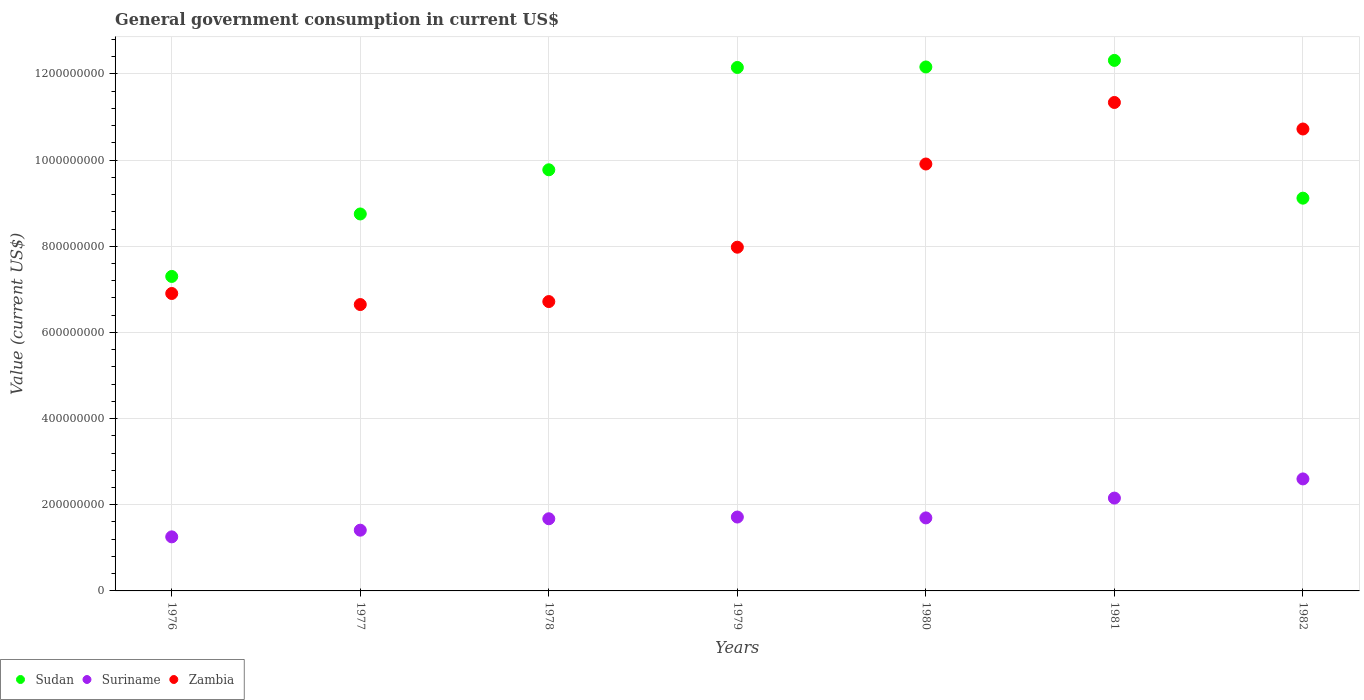Is the number of dotlines equal to the number of legend labels?
Provide a succinct answer. Yes. What is the government conusmption in Suriname in 1979?
Provide a succinct answer. 1.72e+08. Across all years, what is the maximum government conusmption in Zambia?
Your answer should be very brief. 1.13e+09. Across all years, what is the minimum government conusmption in Suriname?
Provide a short and direct response. 1.26e+08. In which year was the government conusmption in Suriname minimum?
Provide a short and direct response. 1976. What is the total government conusmption in Suriname in the graph?
Keep it short and to the point. 1.25e+09. What is the difference between the government conusmption in Sudan in 1976 and that in 1977?
Ensure brevity in your answer.  -1.45e+08. What is the difference between the government conusmption in Zambia in 1978 and the government conusmption in Suriname in 1982?
Your answer should be compact. 4.12e+08. What is the average government conusmption in Zambia per year?
Provide a succinct answer. 8.60e+08. In the year 1980, what is the difference between the government conusmption in Zambia and government conusmption in Suriname?
Your response must be concise. 8.22e+08. What is the ratio of the government conusmption in Sudan in 1976 to that in 1979?
Your response must be concise. 0.6. What is the difference between the highest and the second highest government conusmption in Zambia?
Your answer should be very brief. 6.16e+07. What is the difference between the highest and the lowest government conusmption in Zambia?
Keep it short and to the point. 4.69e+08. Is it the case that in every year, the sum of the government conusmption in Sudan and government conusmption in Suriname  is greater than the government conusmption in Zambia?
Make the answer very short. Yes. Is the government conusmption in Suriname strictly greater than the government conusmption in Sudan over the years?
Your answer should be compact. No. Is the government conusmption in Zambia strictly less than the government conusmption in Sudan over the years?
Make the answer very short. No. How many dotlines are there?
Your answer should be compact. 3. What is the difference between two consecutive major ticks on the Y-axis?
Ensure brevity in your answer.  2.00e+08. Does the graph contain grids?
Ensure brevity in your answer.  Yes. What is the title of the graph?
Your response must be concise. General government consumption in current US$. What is the label or title of the X-axis?
Your answer should be compact. Years. What is the label or title of the Y-axis?
Ensure brevity in your answer.  Value (current US$). What is the Value (current US$) of Sudan in 1976?
Give a very brief answer. 7.30e+08. What is the Value (current US$) in Suriname in 1976?
Provide a succinct answer. 1.26e+08. What is the Value (current US$) of Zambia in 1976?
Offer a very short reply. 6.90e+08. What is the Value (current US$) in Sudan in 1977?
Make the answer very short. 8.75e+08. What is the Value (current US$) of Suriname in 1977?
Keep it short and to the point. 1.41e+08. What is the Value (current US$) in Zambia in 1977?
Offer a very short reply. 6.65e+08. What is the Value (current US$) of Sudan in 1978?
Give a very brief answer. 9.78e+08. What is the Value (current US$) of Suriname in 1978?
Make the answer very short. 1.68e+08. What is the Value (current US$) in Zambia in 1978?
Offer a very short reply. 6.72e+08. What is the Value (current US$) of Sudan in 1979?
Make the answer very short. 1.22e+09. What is the Value (current US$) of Suriname in 1979?
Your response must be concise. 1.72e+08. What is the Value (current US$) in Zambia in 1979?
Provide a succinct answer. 7.98e+08. What is the Value (current US$) in Sudan in 1980?
Provide a short and direct response. 1.22e+09. What is the Value (current US$) in Suriname in 1980?
Make the answer very short. 1.70e+08. What is the Value (current US$) in Zambia in 1980?
Your response must be concise. 9.91e+08. What is the Value (current US$) in Sudan in 1981?
Keep it short and to the point. 1.23e+09. What is the Value (current US$) of Suriname in 1981?
Your response must be concise. 2.16e+08. What is the Value (current US$) in Zambia in 1981?
Offer a very short reply. 1.13e+09. What is the Value (current US$) in Sudan in 1982?
Your answer should be very brief. 9.12e+08. What is the Value (current US$) of Suriname in 1982?
Make the answer very short. 2.60e+08. What is the Value (current US$) in Zambia in 1982?
Your response must be concise. 1.07e+09. Across all years, what is the maximum Value (current US$) in Sudan?
Your response must be concise. 1.23e+09. Across all years, what is the maximum Value (current US$) of Suriname?
Keep it short and to the point. 2.60e+08. Across all years, what is the maximum Value (current US$) of Zambia?
Make the answer very short. 1.13e+09. Across all years, what is the minimum Value (current US$) of Sudan?
Offer a very short reply. 7.30e+08. Across all years, what is the minimum Value (current US$) of Suriname?
Provide a succinct answer. 1.26e+08. Across all years, what is the minimum Value (current US$) of Zambia?
Provide a short and direct response. 6.65e+08. What is the total Value (current US$) in Sudan in the graph?
Provide a succinct answer. 7.16e+09. What is the total Value (current US$) in Suriname in the graph?
Give a very brief answer. 1.25e+09. What is the total Value (current US$) of Zambia in the graph?
Provide a short and direct response. 6.02e+09. What is the difference between the Value (current US$) in Sudan in 1976 and that in 1977?
Your answer should be very brief. -1.45e+08. What is the difference between the Value (current US$) of Suriname in 1976 and that in 1977?
Offer a very short reply. -1.55e+07. What is the difference between the Value (current US$) in Zambia in 1976 and that in 1977?
Your answer should be very brief. 2.57e+07. What is the difference between the Value (current US$) in Sudan in 1976 and that in 1978?
Your answer should be very brief. -2.48e+08. What is the difference between the Value (current US$) in Suriname in 1976 and that in 1978?
Ensure brevity in your answer.  -4.20e+07. What is the difference between the Value (current US$) of Zambia in 1976 and that in 1978?
Your answer should be very brief. 1.88e+07. What is the difference between the Value (current US$) of Sudan in 1976 and that in 1979?
Your answer should be very brief. -4.85e+08. What is the difference between the Value (current US$) in Suriname in 1976 and that in 1979?
Your answer should be very brief. -4.60e+07. What is the difference between the Value (current US$) of Zambia in 1976 and that in 1979?
Provide a succinct answer. -1.07e+08. What is the difference between the Value (current US$) in Sudan in 1976 and that in 1980?
Offer a terse response. -4.86e+08. What is the difference between the Value (current US$) of Suriname in 1976 and that in 1980?
Keep it short and to the point. -4.40e+07. What is the difference between the Value (current US$) in Zambia in 1976 and that in 1980?
Your answer should be compact. -3.01e+08. What is the difference between the Value (current US$) in Sudan in 1976 and that in 1981?
Offer a terse response. -5.02e+08. What is the difference between the Value (current US$) of Suriname in 1976 and that in 1981?
Ensure brevity in your answer.  -9.00e+07. What is the difference between the Value (current US$) in Zambia in 1976 and that in 1981?
Keep it short and to the point. -4.43e+08. What is the difference between the Value (current US$) in Sudan in 1976 and that in 1982?
Ensure brevity in your answer.  -1.82e+08. What is the difference between the Value (current US$) of Suriname in 1976 and that in 1982?
Keep it short and to the point. -1.34e+08. What is the difference between the Value (current US$) in Zambia in 1976 and that in 1982?
Offer a very short reply. -3.82e+08. What is the difference between the Value (current US$) in Sudan in 1977 and that in 1978?
Ensure brevity in your answer.  -1.03e+08. What is the difference between the Value (current US$) of Suriname in 1977 and that in 1978?
Make the answer very short. -2.65e+07. What is the difference between the Value (current US$) in Zambia in 1977 and that in 1978?
Ensure brevity in your answer.  -6.90e+06. What is the difference between the Value (current US$) of Sudan in 1977 and that in 1979?
Ensure brevity in your answer.  -3.40e+08. What is the difference between the Value (current US$) in Suriname in 1977 and that in 1979?
Offer a terse response. -3.05e+07. What is the difference between the Value (current US$) of Zambia in 1977 and that in 1979?
Your answer should be compact. -1.33e+08. What is the difference between the Value (current US$) of Sudan in 1977 and that in 1980?
Provide a short and direct response. -3.41e+08. What is the difference between the Value (current US$) of Suriname in 1977 and that in 1980?
Your answer should be compact. -2.85e+07. What is the difference between the Value (current US$) in Zambia in 1977 and that in 1980?
Keep it short and to the point. -3.26e+08. What is the difference between the Value (current US$) of Sudan in 1977 and that in 1981?
Ensure brevity in your answer.  -3.56e+08. What is the difference between the Value (current US$) in Suriname in 1977 and that in 1981?
Your response must be concise. -7.45e+07. What is the difference between the Value (current US$) of Zambia in 1977 and that in 1981?
Ensure brevity in your answer.  -4.69e+08. What is the difference between the Value (current US$) of Sudan in 1977 and that in 1982?
Keep it short and to the point. -3.67e+07. What is the difference between the Value (current US$) of Suriname in 1977 and that in 1982?
Provide a short and direct response. -1.19e+08. What is the difference between the Value (current US$) of Zambia in 1977 and that in 1982?
Provide a succinct answer. -4.08e+08. What is the difference between the Value (current US$) in Sudan in 1978 and that in 1979?
Ensure brevity in your answer.  -2.38e+08. What is the difference between the Value (current US$) in Zambia in 1978 and that in 1979?
Offer a terse response. -1.26e+08. What is the difference between the Value (current US$) in Sudan in 1978 and that in 1980?
Offer a terse response. -2.39e+08. What is the difference between the Value (current US$) in Zambia in 1978 and that in 1980?
Ensure brevity in your answer.  -3.19e+08. What is the difference between the Value (current US$) of Sudan in 1978 and that in 1981?
Offer a very short reply. -2.54e+08. What is the difference between the Value (current US$) of Suriname in 1978 and that in 1981?
Offer a terse response. -4.80e+07. What is the difference between the Value (current US$) in Zambia in 1978 and that in 1981?
Provide a short and direct response. -4.62e+08. What is the difference between the Value (current US$) in Sudan in 1978 and that in 1982?
Offer a terse response. 6.59e+07. What is the difference between the Value (current US$) in Suriname in 1978 and that in 1982?
Give a very brief answer. -9.25e+07. What is the difference between the Value (current US$) in Zambia in 1978 and that in 1982?
Offer a terse response. -4.01e+08. What is the difference between the Value (current US$) of Sudan in 1979 and that in 1980?
Your answer should be very brief. -1.16e+06. What is the difference between the Value (current US$) in Suriname in 1979 and that in 1980?
Your answer should be compact. 2.00e+06. What is the difference between the Value (current US$) of Zambia in 1979 and that in 1980?
Provide a succinct answer. -1.93e+08. What is the difference between the Value (current US$) of Sudan in 1979 and that in 1981?
Your response must be concise. -1.64e+07. What is the difference between the Value (current US$) in Suriname in 1979 and that in 1981?
Keep it short and to the point. -4.40e+07. What is the difference between the Value (current US$) in Zambia in 1979 and that in 1981?
Provide a succinct answer. -3.36e+08. What is the difference between the Value (current US$) in Sudan in 1979 and that in 1982?
Provide a short and direct response. 3.03e+08. What is the difference between the Value (current US$) of Suriname in 1979 and that in 1982?
Ensure brevity in your answer.  -8.85e+07. What is the difference between the Value (current US$) in Zambia in 1979 and that in 1982?
Your answer should be compact. -2.74e+08. What is the difference between the Value (current US$) of Sudan in 1980 and that in 1981?
Ensure brevity in your answer.  -1.52e+07. What is the difference between the Value (current US$) of Suriname in 1980 and that in 1981?
Your answer should be very brief. -4.60e+07. What is the difference between the Value (current US$) in Zambia in 1980 and that in 1981?
Give a very brief answer. -1.43e+08. What is the difference between the Value (current US$) in Sudan in 1980 and that in 1982?
Provide a succinct answer. 3.05e+08. What is the difference between the Value (current US$) in Suriname in 1980 and that in 1982?
Give a very brief answer. -9.05e+07. What is the difference between the Value (current US$) of Zambia in 1980 and that in 1982?
Your response must be concise. -8.13e+07. What is the difference between the Value (current US$) of Sudan in 1981 and that in 1982?
Your answer should be compact. 3.20e+08. What is the difference between the Value (current US$) of Suriname in 1981 and that in 1982?
Provide a succinct answer. -4.45e+07. What is the difference between the Value (current US$) of Zambia in 1981 and that in 1982?
Provide a succinct answer. 6.16e+07. What is the difference between the Value (current US$) of Sudan in 1976 and the Value (current US$) of Suriname in 1977?
Provide a short and direct response. 5.89e+08. What is the difference between the Value (current US$) in Sudan in 1976 and the Value (current US$) in Zambia in 1977?
Your answer should be very brief. 6.53e+07. What is the difference between the Value (current US$) of Suriname in 1976 and the Value (current US$) of Zambia in 1977?
Your response must be concise. -5.39e+08. What is the difference between the Value (current US$) of Sudan in 1976 and the Value (current US$) of Suriname in 1978?
Make the answer very short. 5.63e+08. What is the difference between the Value (current US$) of Sudan in 1976 and the Value (current US$) of Zambia in 1978?
Make the answer very short. 5.83e+07. What is the difference between the Value (current US$) in Suriname in 1976 and the Value (current US$) in Zambia in 1978?
Give a very brief answer. -5.46e+08. What is the difference between the Value (current US$) in Sudan in 1976 and the Value (current US$) in Suriname in 1979?
Provide a succinct answer. 5.59e+08. What is the difference between the Value (current US$) in Sudan in 1976 and the Value (current US$) in Zambia in 1979?
Offer a very short reply. -6.79e+07. What is the difference between the Value (current US$) of Suriname in 1976 and the Value (current US$) of Zambia in 1979?
Ensure brevity in your answer.  -6.72e+08. What is the difference between the Value (current US$) of Sudan in 1976 and the Value (current US$) of Suriname in 1980?
Your answer should be very brief. 5.61e+08. What is the difference between the Value (current US$) in Sudan in 1976 and the Value (current US$) in Zambia in 1980?
Offer a terse response. -2.61e+08. What is the difference between the Value (current US$) in Suriname in 1976 and the Value (current US$) in Zambia in 1980?
Offer a terse response. -8.66e+08. What is the difference between the Value (current US$) in Sudan in 1976 and the Value (current US$) in Suriname in 1981?
Provide a short and direct response. 5.15e+08. What is the difference between the Value (current US$) in Sudan in 1976 and the Value (current US$) in Zambia in 1981?
Ensure brevity in your answer.  -4.04e+08. What is the difference between the Value (current US$) in Suriname in 1976 and the Value (current US$) in Zambia in 1981?
Offer a terse response. -1.01e+09. What is the difference between the Value (current US$) in Sudan in 1976 and the Value (current US$) in Suriname in 1982?
Keep it short and to the point. 4.70e+08. What is the difference between the Value (current US$) in Sudan in 1976 and the Value (current US$) in Zambia in 1982?
Provide a succinct answer. -3.42e+08. What is the difference between the Value (current US$) in Suriname in 1976 and the Value (current US$) in Zambia in 1982?
Make the answer very short. -9.47e+08. What is the difference between the Value (current US$) in Sudan in 1977 and the Value (current US$) in Suriname in 1978?
Keep it short and to the point. 7.08e+08. What is the difference between the Value (current US$) of Sudan in 1977 and the Value (current US$) of Zambia in 1978?
Provide a succinct answer. 2.03e+08. What is the difference between the Value (current US$) of Suriname in 1977 and the Value (current US$) of Zambia in 1978?
Give a very brief answer. -5.31e+08. What is the difference between the Value (current US$) of Sudan in 1977 and the Value (current US$) of Suriname in 1979?
Make the answer very short. 7.04e+08. What is the difference between the Value (current US$) of Sudan in 1977 and the Value (current US$) of Zambia in 1979?
Keep it short and to the point. 7.72e+07. What is the difference between the Value (current US$) of Suriname in 1977 and the Value (current US$) of Zambia in 1979?
Your answer should be very brief. -6.57e+08. What is the difference between the Value (current US$) of Sudan in 1977 and the Value (current US$) of Suriname in 1980?
Offer a very short reply. 7.06e+08. What is the difference between the Value (current US$) in Sudan in 1977 and the Value (current US$) in Zambia in 1980?
Offer a terse response. -1.16e+08. What is the difference between the Value (current US$) of Suriname in 1977 and the Value (current US$) of Zambia in 1980?
Ensure brevity in your answer.  -8.50e+08. What is the difference between the Value (current US$) of Sudan in 1977 and the Value (current US$) of Suriname in 1981?
Offer a very short reply. 6.60e+08. What is the difference between the Value (current US$) of Sudan in 1977 and the Value (current US$) of Zambia in 1981?
Provide a short and direct response. -2.59e+08. What is the difference between the Value (current US$) in Suriname in 1977 and the Value (current US$) in Zambia in 1981?
Your answer should be very brief. -9.93e+08. What is the difference between the Value (current US$) in Sudan in 1977 and the Value (current US$) in Suriname in 1982?
Make the answer very short. 6.15e+08. What is the difference between the Value (current US$) in Sudan in 1977 and the Value (current US$) in Zambia in 1982?
Keep it short and to the point. -1.97e+08. What is the difference between the Value (current US$) of Suriname in 1977 and the Value (current US$) of Zambia in 1982?
Your answer should be compact. -9.31e+08. What is the difference between the Value (current US$) in Sudan in 1978 and the Value (current US$) in Suriname in 1979?
Offer a very short reply. 8.06e+08. What is the difference between the Value (current US$) in Sudan in 1978 and the Value (current US$) in Zambia in 1979?
Provide a succinct answer. 1.80e+08. What is the difference between the Value (current US$) of Suriname in 1978 and the Value (current US$) of Zambia in 1979?
Offer a terse response. -6.30e+08. What is the difference between the Value (current US$) of Sudan in 1978 and the Value (current US$) of Suriname in 1980?
Give a very brief answer. 8.08e+08. What is the difference between the Value (current US$) in Sudan in 1978 and the Value (current US$) in Zambia in 1980?
Offer a very short reply. -1.34e+07. What is the difference between the Value (current US$) of Suriname in 1978 and the Value (current US$) of Zambia in 1980?
Offer a very short reply. -8.24e+08. What is the difference between the Value (current US$) of Sudan in 1978 and the Value (current US$) of Suriname in 1981?
Provide a short and direct response. 7.62e+08. What is the difference between the Value (current US$) in Sudan in 1978 and the Value (current US$) in Zambia in 1981?
Offer a terse response. -1.56e+08. What is the difference between the Value (current US$) in Suriname in 1978 and the Value (current US$) in Zambia in 1981?
Your answer should be very brief. -9.66e+08. What is the difference between the Value (current US$) in Sudan in 1978 and the Value (current US$) in Suriname in 1982?
Your answer should be very brief. 7.18e+08. What is the difference between the Value (current US$) in Sudan in 1978 and the Value (current US$) in Zambia in 1982?
Keep it short and to the point. -9.47e+07. What is the difference between the Value (current US$) of Suriname in 1978 and the Value (current US$) of Zambia in 1982?
Your answer should be very brief. -9.05e+08. What is the difference between the Value (current US$) of Sudan in 1979 and the Value (current US$) of Suriname in 1980?
Provide a succinct answer. 1.05e+09. What is the difference between the Value (current US$) of Sudan in 1979 and the Value (current US$) of Zambia in 1980?
Provide a succinct answer. 2.24e+08. What is the difference between the Value (current US$) of Suriname in 1979 and the Value (current US$) of Zambia in 1980?
Provide a short and direct response. -8.20e+08. What is the difference between the Value (current US$) in Sudan in 1979 and the Value (current US$) in Suriname in 1981?
Your answer should be very brief. 1.00e+09. What is the difference between the Value (current US$) of Sudan in 1979 and the Value (current US$) of Zambia in 1981?
Your response must be concise. 8.13e+07. What is the difference between the Value (current US$) of Suriname in 1979 and the Value (current US$) of Zambia in 1981?
Your answer should be compact. -9.62e+08. What is the difference between the Value (current US$) in Sudan in 1979 and the Value (current US$) in Suriname in 1982?
Provide a succinct answer. 9.55e+08. What is the difference between the Value (current US$) of Sudan in 1979 and the Value (current US$) of Zambia in 1982?
Your answer should be very brief. 1.43e+08. What is the difference between the Value (current US$) in Suriname in 1979 and the Value (current US$) in Zambia in 1982?
Make the answer very short. -9.01e+08. What is the difference between the Value (current US$) of Sudan in 1980 and the Value (current US$) of Suriname in 1981?
Provide a short and direct response. 1.00e+09. What is the difference between the Value (current US$) of Sudan in 1980 and the Value (current US$) of Zambia in 1981?
Provide a short and direct response. 8.24e+07. What is the difference between the Value (current US$) of Suriname in 1980 and the Value (current US$) of Zambia in 1981?
Give a very brief answer. -9.64e+08. What is the difference between the Value (current US$) in Sudan in 1980 and the Value (current US$) in Suriname in 1982?
Your response must be concise. 9.56e+08. What is the difference between the Value (current US$) of Sudan in 1980 and the Value (current US$) of Zambia in 1982?
Your answer should be very brief. 1.44e+08. What is the difference between the Value (current US$) of Suriname in 1980 and the Value (current US$) of Zambia in 1982?
Offer a terse response. -9.03e+08. What is the difference between the Value (current US$) in Sudan in 1981 and the Value (current US$) in Suriname in 1982?
Ensure brevity in your answer.  9.72e+08. What is the difference between the Value (current US$) in Sudan in 1981 and the Value (current US$) in Zambia in 1982?
Provide a short and direct response. 1.59e+08. What is the difference between the Value (current US$) in Suriname in 1981 and the Value (current US$) in Zambia in 1982?
Offer a terse response. -8.57e+08. What is the average Value (current US$) of Sudan per year?
Your answer should be compact. 1.02e+09. What is the average Value (current US$) in Suriname per year?
Offer a terse response. 1.79e+08. What is the average Value (current US$) in Zambia per year?
Provide a succinct answer. 8.60e+08. In the year 1976, what is the difference between the Value (current US$) of Sudan and Value (current US$) of Suriname?
Offer a terse response. 6.05e+08. In the year 1976, what is the difference between the Value (current US$) of Sudan and Value (current US$) of Zambia?
Make the answer very short. 3.96e+07. In the year 1976, what is the difference between the Value (current US$) of Suriname and Value (current US$) of Zambia?
Your answer should be compact. -5.65e+08. In the year 1977, what is the difference between the Value (current US$) in Sudan and Value (current US$) in Suriname?
Your answer should be very brief. 7.34e+08. In the year 1977, what is the difference between the Value (current US$) in Sudan and Value (current US$) in Zambia?
Your response must be concise. 2.10e+08. In the year 1977, what is the difference between the Value (current US$) of Suriname and Value (current US$) of Zambia?
Offer a terse response. -5.24e+08. In the year 1978, what is the difference between the Value (current US$) in Sudan and Value (current US$) in Suriname?
Your answer should be very brief. 8.10e+08. In the year 1978, what is the difference between the Value (current US$) of Sudan and Value (current US$) of Zambia?
Offer a terse response. 3.06e+08. In the year 1978, what is the difference between the Value (current US$) in Suriname and Value (current US$) in Zambia?
Give a very brief answer. -5.04e+08. In the year 1979, what is the difference between the Value (current US$) in Sudan and Value (current US$) in Suriname?
Keep it short and to the point. 1.04e+09. In the year 1979, what is the difference between the Value (current US$) of Sudan and Value (current US$) of Zambia?
Keep it short and to the point. 4.17e+08. In the year 1979, what is the difference between the Value (current US$) in Suriname and Value (current US$) in Zambia?
Provide a short and direct response. -6.26e+08. In the year 1980, what is the difference between the Value (current US$) of Sudan and Value (current US$) of Suriname?
Keep it short and to the point. 1.05e+09. In the year 1980, what is the difference between the Value (current US$) of Sudan and Value (current US$) of Zambia?
Your answer should be compact. 2.25e+08. In the year 1980, what is the difference between the Value (current US$) in Suriname and Value (current US$) in Zambia?
Make the answer very short. -8.22e+08. In the year 1981, what is the difference between the Value (current US$) of Sudan and Value (current US$) of Suriname?
Your response must be concise. 1.02e+09. In the year 1981, what is the difference between the Value (current US$) of Sudan and Value (current US$) of Zambia?
Provide a short and direct response. 9.77e+07. In the year 1981, what is the difference between the Value (current US$) in Suriname and Value (current US$) in Zambia?
Your response must be concise. -9.18e+08. In the year 1982, what is the difference between the Value (current US$) of Sudan and Value (current US$) of Suriname?
Offer a very short reply. 6.52e+08. In the year 1982, what is the difference between the Value (current US$) of Sudan and Value (current US$) of Zambia?
Provide a short and direct response. -1.61e+08. In the year 1982, what is the difference between the Value (current US$) of Suriname and Value (current US$) of Zambia?
Provide a short and direct response. -8.12e+08. What is the ratio of the Value (current US$) in Sudan in 1976 to that in 1977?
Keep it short and to the point. 0.83. What is the ratio of the Value (current US$) of Suriname in 1976 to that in 1977?
Give a very brief answer. 0.89. What is the ratio of the Value (current US$) in Zambia in 1976 to that in 1977?
Give a very brief answer. 1.04. What is the ratio of the Value (current US$) in Sudan in 1976 to that in 1978?
Ensure brevity in your answer.  0.75. What is the ratio of the Value (current US$) in Suriname in 1976 to that in 1978?
Ensure brevity in your answer.  0.75. What is the ratio of the Value (current US$) in Zambia in 1976 to that in 1978?
Your answer should be compact. 1.03. What is the ratio of the Value (current US$) in Sudan in 1976 to that in 1979?
Offer a terse response. 0.6. What is the ratio of the Value (current US$) in Suriname in 1976 to that in 1979?
Ensure brevity in your answer.  0.73. What is the ratio of the Value (current US$) in Zambia in 1976 to that in 1979?
Ensure brevity in your answer.  0.87. What is the ratio of the Value (current US$) in Sudan in 1976 to that in 1980?
Provide a succinct answer. 0.6. What is the ratio of the Value (current US$) of Suriname in 1976 to that in 1980?
Your answer should be compact. 0.74. What is the ratio of the Value (current US$) in Zambia in 1976 to that in 1980?
Ensure brevity in your answer.  0.7. What is the ratio of the Value (current US$) of Sudan in 1976 to that in 1981?
Provide a succinct answer. 0.59. What is the ratio of the Value (current US$) of Suriname in 1976 to that in 1981?
Ensure brevity in your answer.  0.58. What is the ratio of the Value (current US$) of Zambia in 1976 to that in 1981?
Make the answer very short. 0.61. What is the ratio of the Value (current US$) of Sudan in 1976 to that in 1982?
Make the answer very short. 0.8. What is the ratio of the Value (current US$) of Suriname in 1976 to that in 1982?
Your answer should be compact. 0.48. What is the ratio of the Value (current US$) of Zambia in 1976 to that in 1982?
Offer a very short reply. 0.64. What is the ratio of the Value (current US$) of Sudan in 1977 to that in 1978?
Make the answer very short. 0.9. What is the ratio of the Value (current US$) in Suriname in 1977 to that in 1978?
Give a very brief answer. 0.84. What is the ratio of the Value (current US$) in Sudan in 1977 to that in 1979?
Make the answer very short. 0.72. What is the ratio of the Value (current US$) in Suriname in 1977 to that in 1979?
Keep it short and to the point. 0.82. What is the ratio of the Value (current US$) of Zambia in 1977 to that in 1979?
Your response must be concise. 0.83. What is the ratio of the Value (current US$) in Sudan in 1977 to that in 1980?
Provide a short and direct response. 0.72. What is the ratio of the Value (current US$) in Suriname in 1977 to that in 1980?
Make the answer very short. 0.83. What is the ratio of the Value (current US$) of Zambia in 1977 to that in 1980?
Ensure brevity in your answer.  0.67. What is the ratio of the Value (current US$) of Sudan in 1977 to that in 1981?
Offer a terse response. 0.71. What is the ratio of the Value (current US$) of Suriname in 1977 to that in 1981?
Offer a very short reply. 0.65. What is the ratio of the Value (current US$) of Zambia in 1977 to that in 1981?
Offer a very short reply. 0.59. What is the ratio of the Value (current US$) in Sudan in 1977 to that in 1982?
Offer a terse response. 0.96. What is the ratio of the Value (current US$) in Suriname in 1977 to that in 1982?
Your response must be concise. 0.54. What is the ratio of the Value (current US$) in Zambia in 1977 to that in 1982?
Give a very brief answer. 0.62. What is the ratio of the Value (current US$) in Sudan in 1978 to that in 1979?
Keep it short and to the point. 0.8. What is the ratio of the Value (current US$) of Suriname in 1978 to that in 1979?
Make the answer very short. 0.98. What is the ratio of the Value (current US$) of Zambia in 1978 to that in 1979?
Your response must be concise. 0.84. What is the ratio of the Value (current US$) of Sudan in 1978 to that in 1980?
Give a very brief answer. 0.8. What is the ratio of the Value (current US$) of Suriname in 1978 to that in 1980?
Keep it short and to the point. 0.99. What is the ratio of the Value (current US$) of Zambia in 1978 to that in 1980?
Give a very brief answer. 0.68. What is the ratio of the Value (current US$) in Sudan in 1978 to that in 1981?
Give a very brief answer. 0.79. What is the ratio of the Value (current US$) in Suriname in 1978 to that in 1981?
Give a very brief answer. 0.78. What is the ratio of the Value (current US$) in Zambia in 1978 to that in 1981?
Keep it short and to the point. 0.59. What is the ratio of the Value (current US$) in Sudan in 1978 to that in 1982?
Provide a succinct answer. 1.07. What is the ratio of the Value (current US$) in Suriname in 1978 to that in 1982?
Keep it short and to the point. 0.64. What is the ratio of the Value (current US$) of Zambia in 1978 to that in 1982?
Offer a terse response. 0.63. What is the ratio of the Value (current US$) in Sudan in 1979 to that in 1980?
Give a very brief answer. 1. What is the ratio of the Value (current US$) of Suriname in 1979 to that in 1980?
Your response must be concise. 1.01. What is the ratio of the Value (current US$) in Zambia in 1979 to that in 1980?
Make the answer very short. 0.81. What is the ratio of the Value (current US$) in Sudan in 1979 to that in 1981?
Your answer should be very brief. 0.99. What is the ratio of the Value (current US$) in Suriname in 1979 to that in 1981?
Provide a short and direct response. 0.8. What is the ratio of the Value (current US$) in Zambia in 1979 to that in 1981?
Keep it short and to the point. 0.7. What is the ratio of the Value (current US$) of Sudan in 1979 to that in 1982?
Provide a succinct answer. 1.33. What is the ratio of the Value (current US$) in Suriname in 1979 to that in 1982?
Your answer should be very brief. 0.66. What is the ratio of the Value (current US$) in Zambia in 1979 to that in 1982?
Provide a succinct answer. 0.74. What is the ratio of the Value (current US$) of Sudan in 1980 to that in 1981?
Keep it short and to the point. 0.99. What is the ratio of the Value (current US$) of Suriname in 1980 to that in 1981?
Give a very brief answer. 0.79. What is the ratio of the Value (current US$) of Zambia in 1980 to that in 1981?
Provide a short and direct response. 0.87. What is the ratio of the Value (current US$) of Sudan in 1980 to that in 1982?
Your answer should be very brief. 1.33. What is the ratio of the Value (current US$) of Suriname in 1980 to that in 1982?
Make the answer very short. 0.65. What is the ratio of the Value (current US$) in Zambia in 1980 to that in 1982?
Give a very brief answer. 0.92. What is the ratio of the Value (current US$) in Sudan in 1981 to that in 1982?
Your answer should be very brief. 1.35. What is the ratio of the Value (current US$) of Suriname in 1981 to that in 1982?
Your answer should be compact. 0.83. What is the ratio of the Value (current US$) of Zambia in 1981 to that in 1982?
Keep it short and to the point. 1.06. What is the difference between the highest and the second highest Value (current US$) of Sudan?
Your answer should be compact. 1.52e+07. What is the difference between the highest and the second highest Value (current US$) in Suriname?
Provide a succinct answer. 4.45e+07. What is the difference between the highest and the second highest Value (current US$) of Zambia?
Offer a terse response. 6.16e+07. What is the difference between the highest and the lowest Value (current US$) in Sudan?
Keep it short and to the point. 5.02e+08. What is the difference between the highest and the lowest Value (current US$) of Suriname?
Provide a short and direct response. 1.34e+08. What is the difference between the highest and the lowest Value (current US$) in Zambia?
Keep it short and to the point. 4.69e+08. 